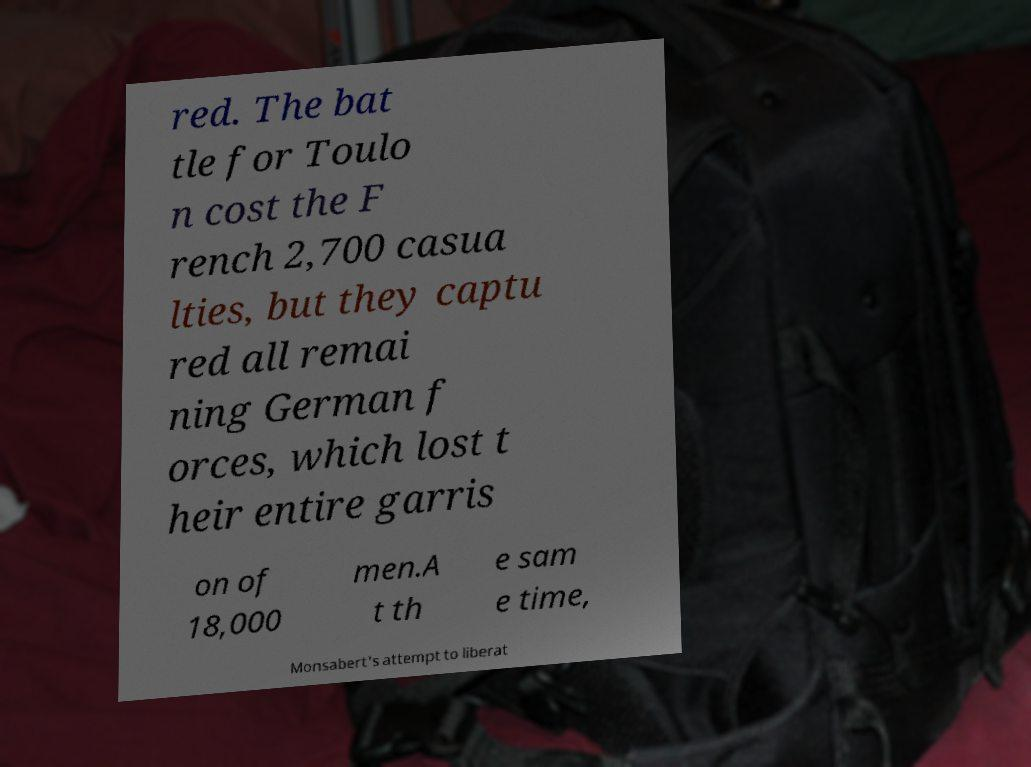Please read and relay the text visible in this image. What does it say? red. The bat tle for Toulo n cost the F rench 2,700 casua lties, but they captu red all remai ning German f orces, which lost t heir entire garris on of 18,000 men.A t th e sam e time, Monsabert's attempt to liberat 